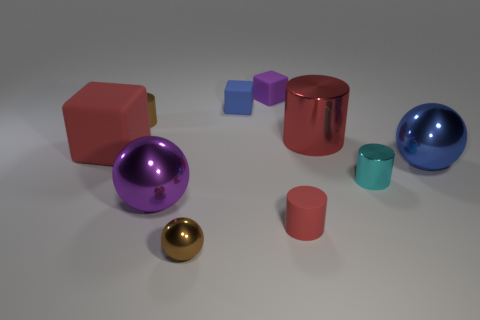Subtract all cubes. How many objects are left? 7 Add 2 blue matte blocks. How many blue matte blocks are left? 3 Add 2 blue matte blocks. How many blue matte blocks exist? 3 Subtract 1 purple blocks. How many objects are left? 9 Subtract all small spheres. Subtract all blue metal blocks. How many objects are left? 9 